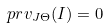<formula> <loc_0><loc_0><loc_500><loc_500>p r v _ { J \Theta } ( I ) = 0</formula> 